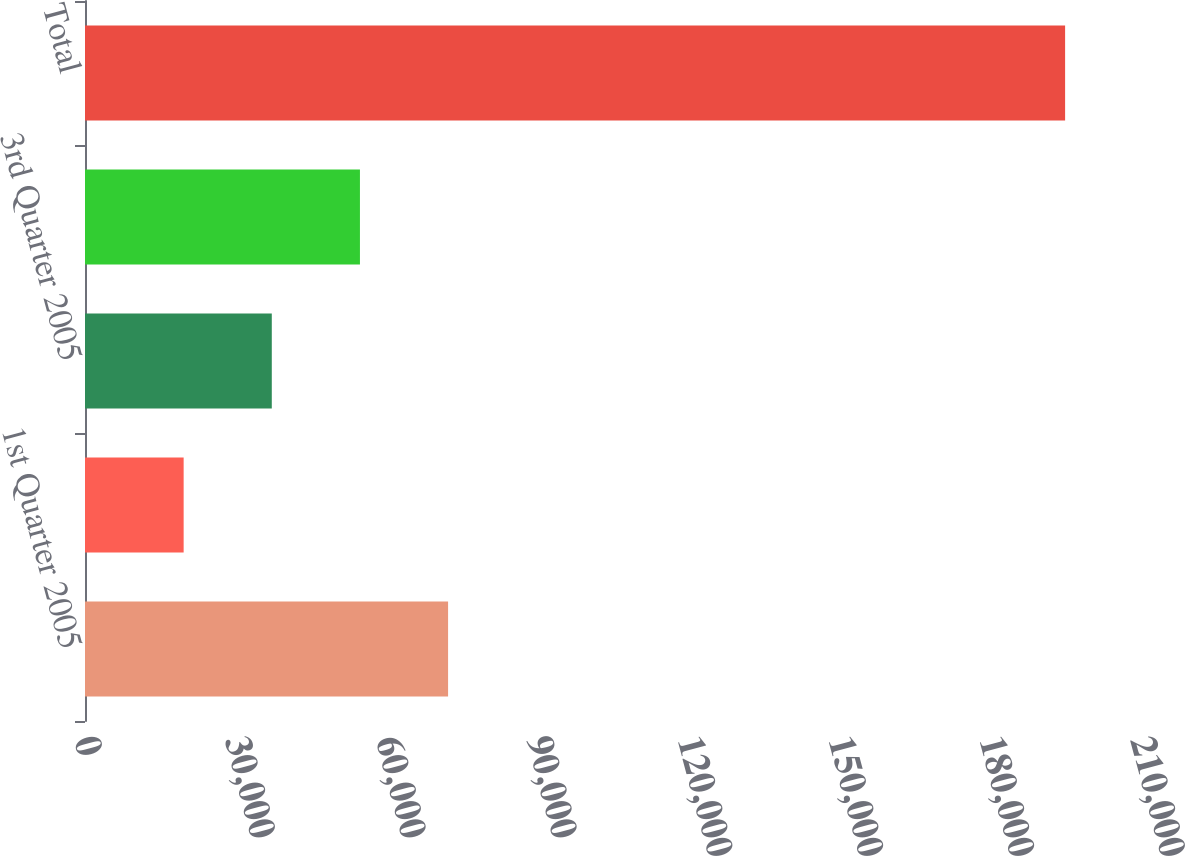Convert chart to OTSL. <chart><loc_0><loc_0><loc_500><loc_500><bar_chart><fcel>1st Quarter 2005<fcel>2nd Quarter 2005<fcel>3rd Quarter 2005<fcel>Thereafter<fcel>Total<nl><fcel>72204.3<fcel>19617<fcel>37146.1<fcel>54675.2<fcel>194908<nl></chart> 